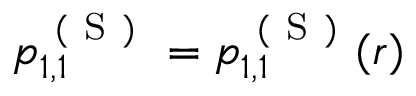<formula> <loc_0><loc_0><loc_500><loc_500>p _ { 1 , 1 } ^ { ( S ) } = p _ { 1 , 1 } ^ { ( S ) } ( r )</formula> 